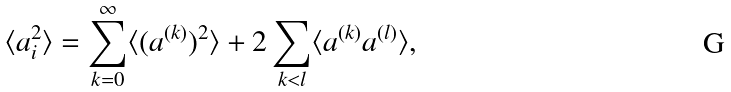<formula> <loc_0><loc_0><loc_500><loc_500>\langle a _ { i } ^ { 2 } \rangle = \sum _ { k = 0 } ^ { \infty } \langle ( a ^ { ( k ) } ) ^ { 2 } \rangle + 2 \sum _ { k < l } \langle a ^ { ( k ) } a ^ { ( l ) } \rangle ,</formula> 